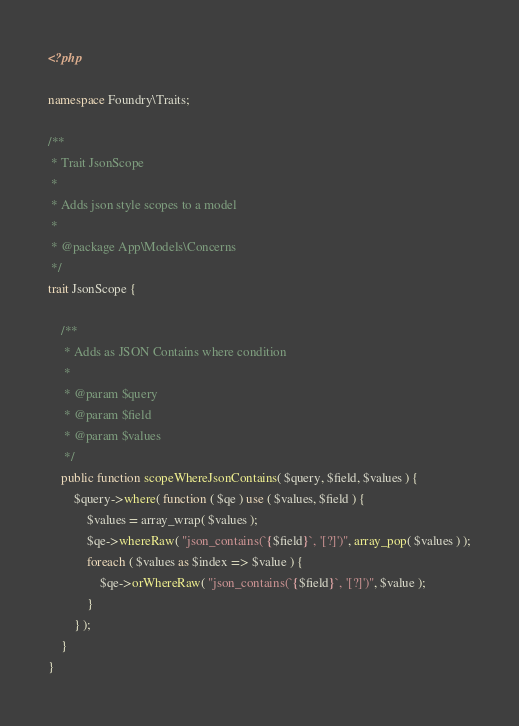Convert code to text. <code><loc_0><loc_0><loc_500><loc_500><_PHP_><?php

namespace Foundry\Traits;

/**
 * Trait JsonScope
 *
 * Adds json style scopes to a model
 *
 * @package App\Models\Concerns
 */
trait JsonScope {

	/**
	 * Adds as JSON Contains where condition
	 *
	 * @param $query
	 * @param $field
	 * @param $values
	 */
	public function scopeWhereJsonContains( $query, $field, $values ) {
		$query->where( function ( $qe ) use ( $values, $field ) {
			$values = array_wrap( $values );
			$qe->whereRaw( "json_contains(`{$field}`, '[?]')", array_pop( $values ) );
			foreach ( $values as $index => $value ) {
				$qe->orWhereRaw( "json_contains(`{$field}`, '[?]')", $value );
			}
		} );
	}
}</code> 